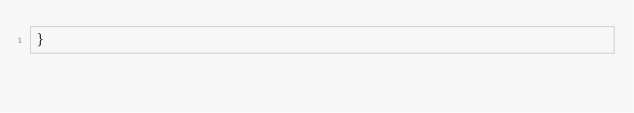Convert code to text. <code><loc_0><loc_0><loc_500><loc_500><_JavaScript_>}
</code> 